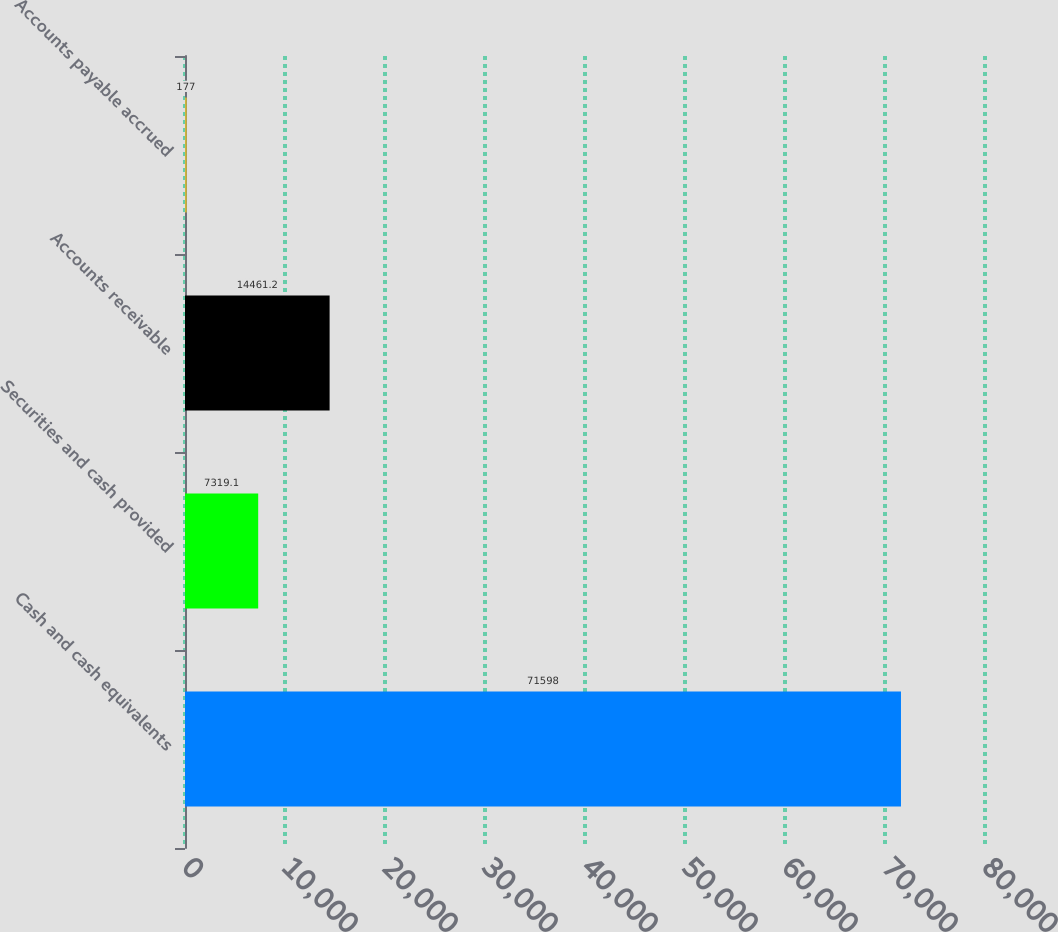Convert chart. <chart><loc_0><loc_0><loc_500><loc_500><bar_chart><fcel>Cash and cash equivalents<fcel>Securities and cash provided<fcel>Accounts receivable<fcel>Accounts payable accrued<nl><fcel>71598<fcel>7319.1<fcel>14461.2<fcel>177<nl></chart> 